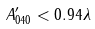Convert formula to latex. <formula><loc_0><loc_0><loc_500><loc_500>A ^ { \prime } _ { 0 4 0 } < 0 . 9 4 \lambda</formula> 